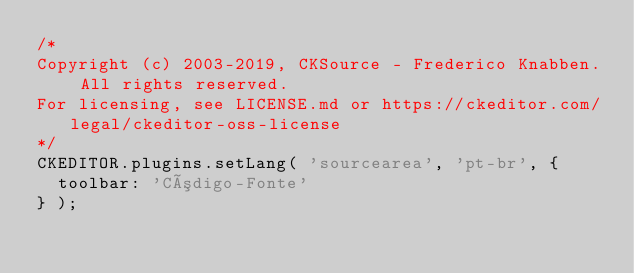<code> <loc_0><loc_0><loc_500><loc_500><_JavaScript_>/*
Copyright (c) 2003-2019, CKSource - Frederico Knabben. All rights reserved.
For licensing, see LICENSE.md or https://ckeditor.com/legal/ckeditor-oss-license
*/
CKEDITOR.plugins.setLang( 'sourcearea', 'pt-br', {
	toolbar: 'Código-Fonte'
} );
</code> 